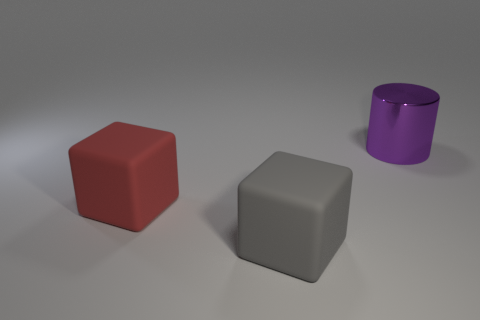There is a metal thing; is its shape the same as the rubber thing in front of the red rubber thing?
Your response must be concise. No. Are there more gray cylinders than cylinders?
Your answer should be compact. No. What number of objects are behind the big gray matte cube and left of the purple cylinder?
Ensure brevity in your answer.  1. What shape is the large object right of the big object in front of the object left of the large gray thing?
Offer a very short reply. Cylinder. Is there anything else that is the same shape as the gray matte object?
Offer a very short reply. Yes. What number of cubes are green shiny things or purple objects?
Ensure brevity in your answer.  0. There is a large block to the right of the object that is left of the rubber thing to the right of the large red rubber block; what is it made of?
Give a very brief answer. Rubber. Do the gray rubber cube and the purple shiny object have the same size?
Ensure brevity in your answer.  Yes. There is a gray thing that is the same material as the large red thing; what shape is it?
Keep it short and to the point. Cube. There is a rubber object that is behind the gray rubber block; does it have the same shape as the big gray rubber thing?
Make the answer very short. Yes. 